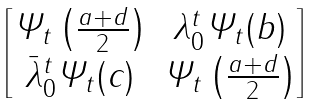Convert formula to latex. <formula><loc_0><loc_0><loc_500><loc_500>\begin{bmatrix} \varPsi _ { t } \left ( \frac { a + d } { 2 } \right ) & \lambda _ { 0 } ^ { t } \varPsi _ { t } ( b ) \\ \bar { \lambda } _ { 0 } ^ { t } \varPsi _ { t } ( c ) & \varPsi _ { t } \left ( \frac { a + d } { 2 } \right ) \end{bmatrix}</formula> 